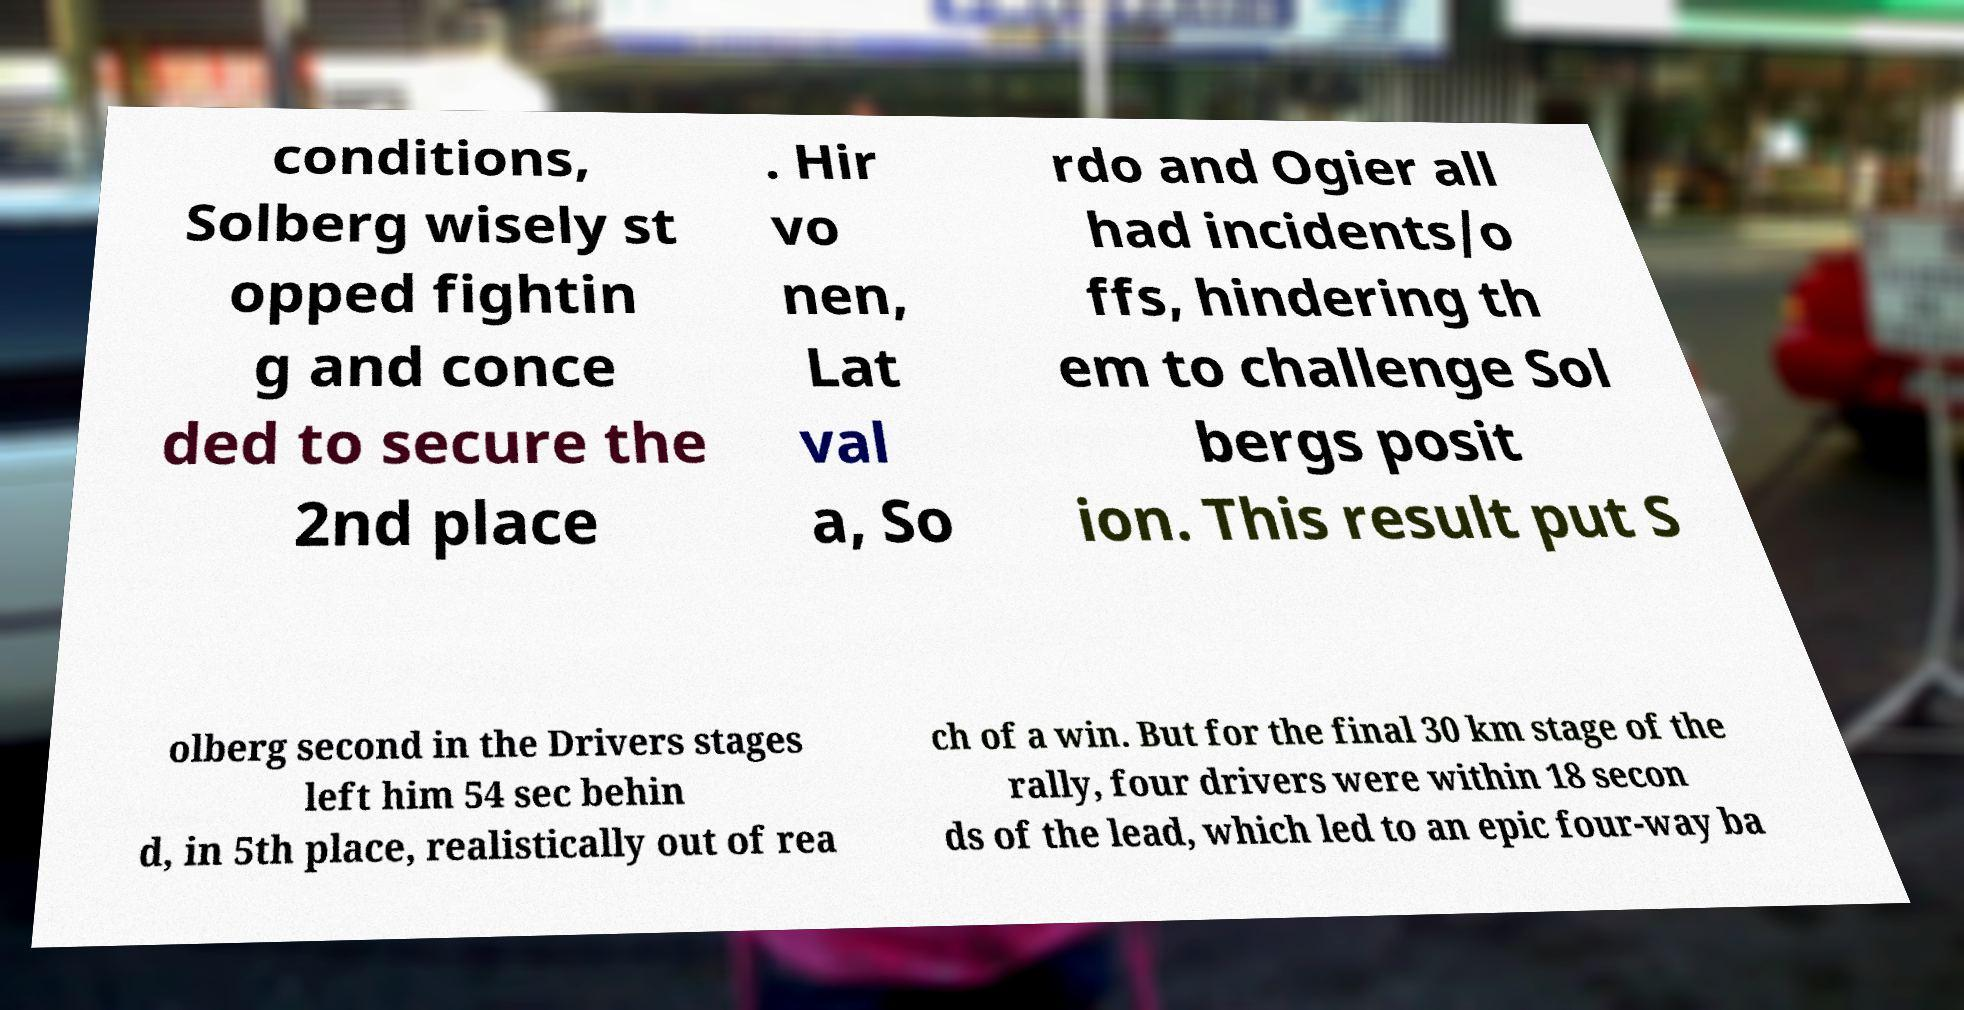Could you assist in decoding the text presented in this image and type it out clearly? conditions, Solberg wisely st opped fightin g and conce ded to secure the 2nd place . Hir vo nen, Lat val a, So rdo and Ogier all had incidents/o ffs, hindering th em to challenge Sol bergs posit ion. This result put S olberg second in the Drivers stages left him 54 sec behin d, in 5th place, realistically out of rea ch of a win. But for the final 30 km stage of the rally, four drivers were within 18 secon ds of the lead, which led to an epic four-way ba 